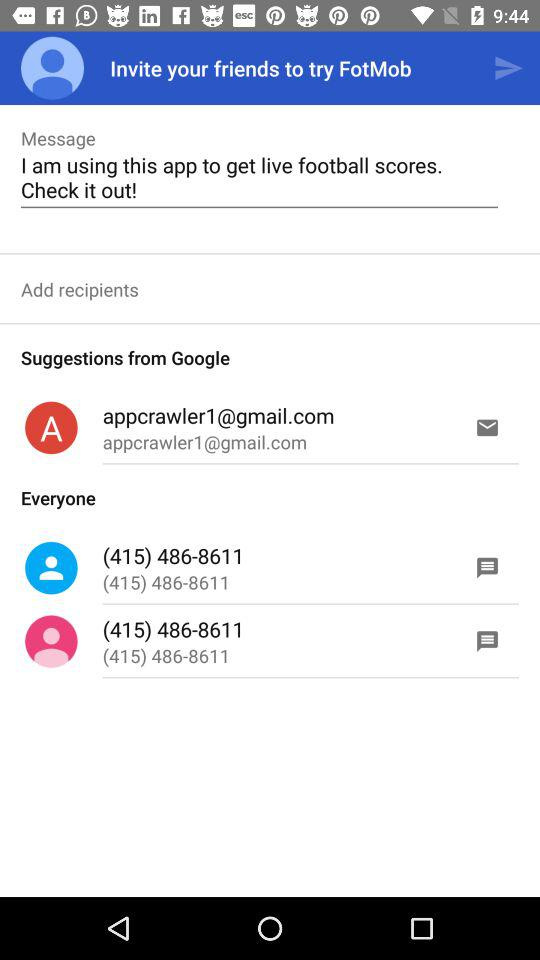What is the message here? The message is "I am using this app to get live football scores. Check it out!". 